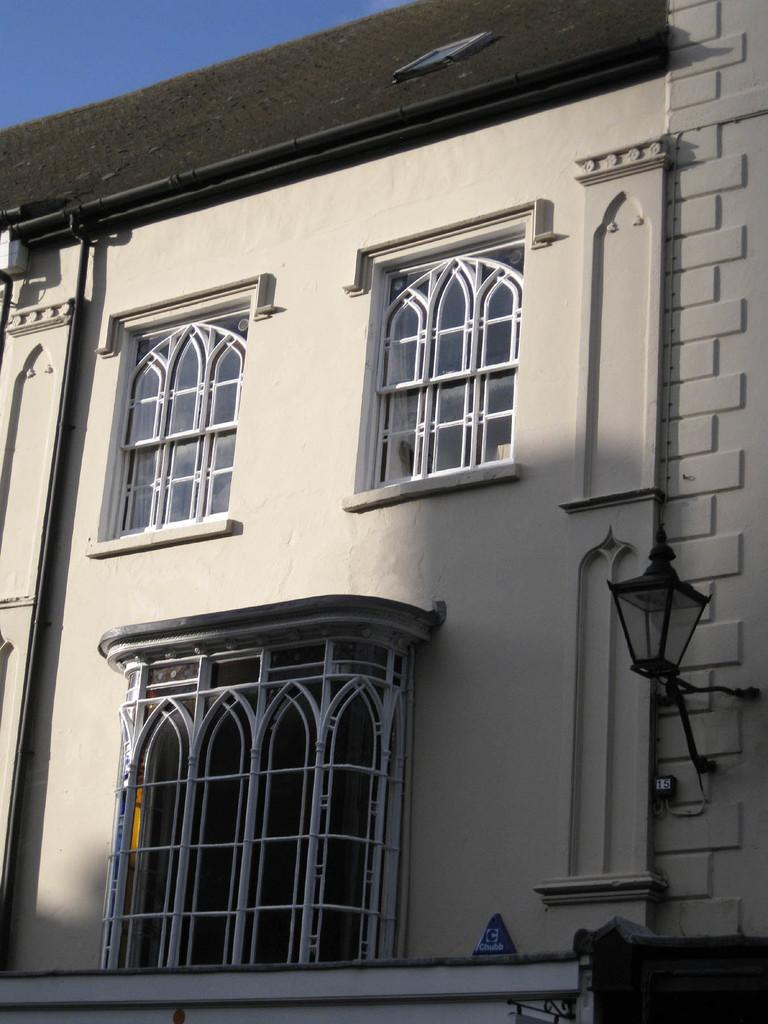What type of structure is present in the image? There is a building in the image. What feature can be seen on the building? The building has windows. What object is visible in the image besides the building? There is a lamp in the image. What color is the sweater worn by the yak in the image? There is no sweater or yak present in the image; it only features a building and a lamp. 